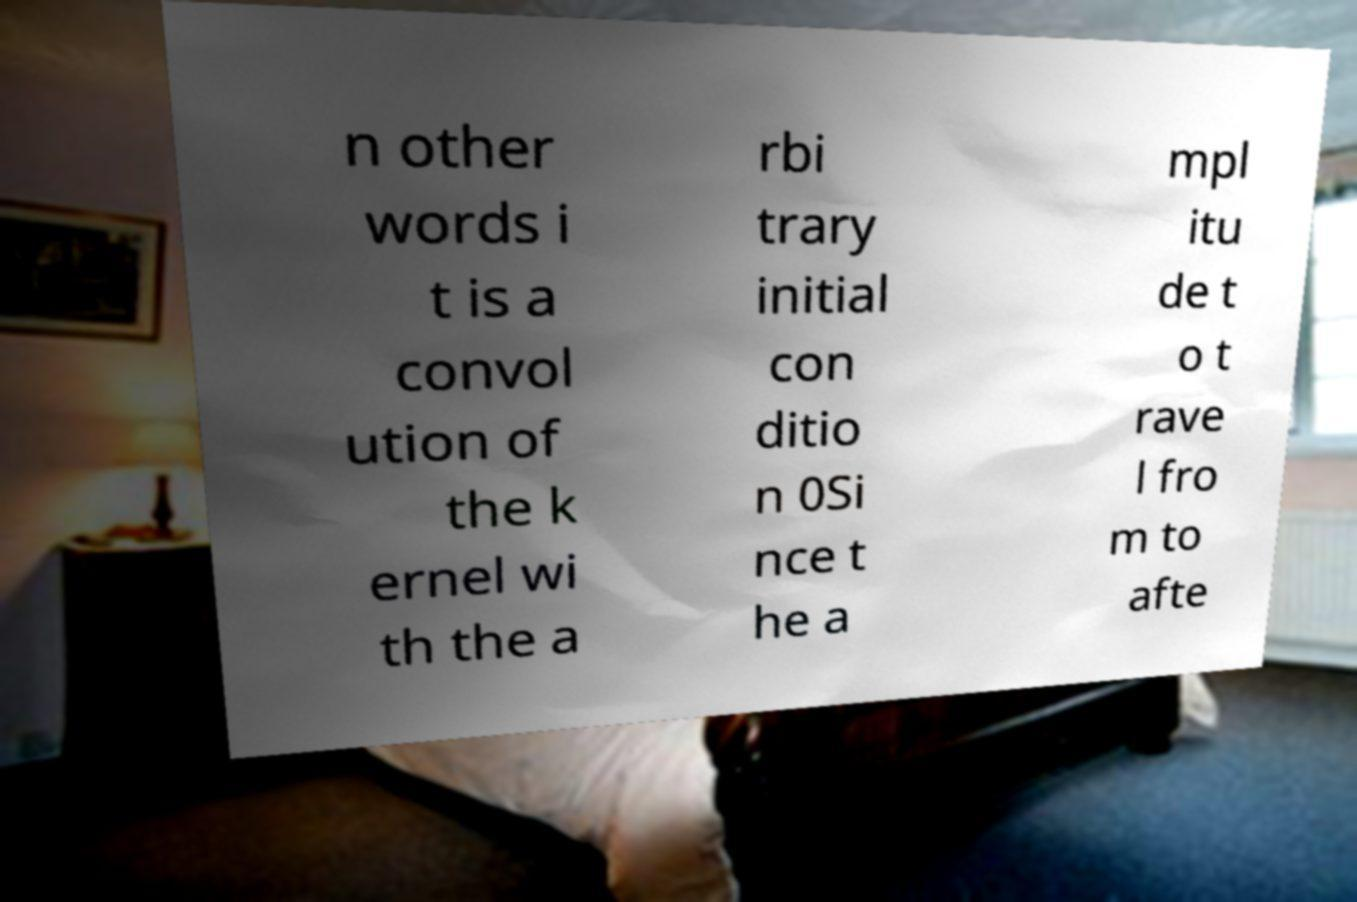There's text embedded in this image that I need extracted. Can you transcribe it verbatim? n other words i t is a convol ution of the k ernel wi th the a rbi trary initial con ditio n 0Si nce t he a mpl itu de t o t rave l fro m to afte 